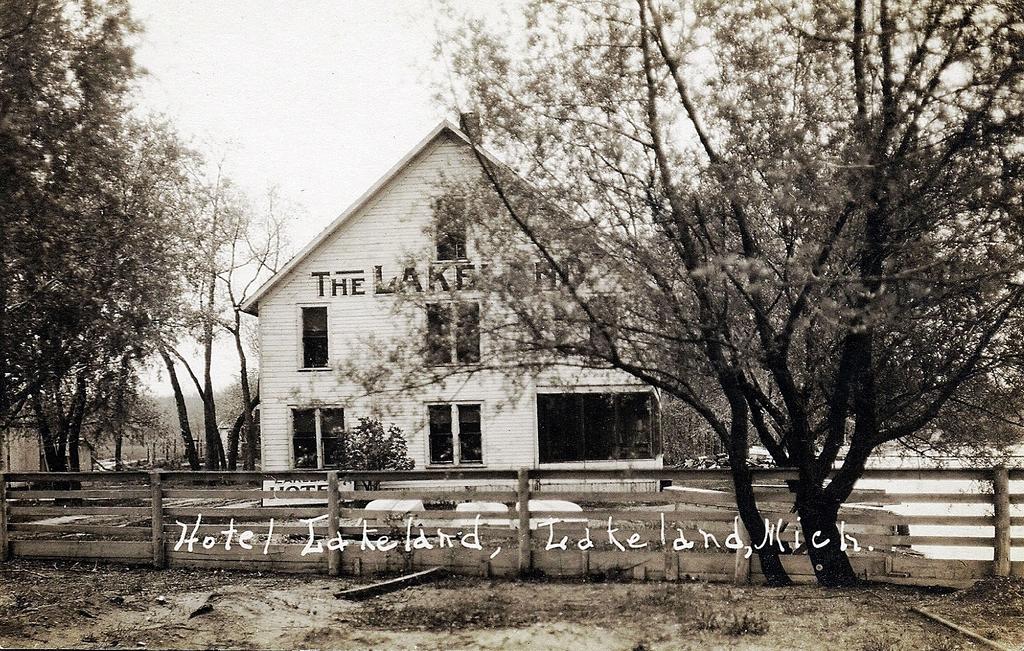What island is labelled in the photo?
Give a very brief answer. Lakeland. Is this photo taken in michigan?
Give a very brief answer. Yes. 